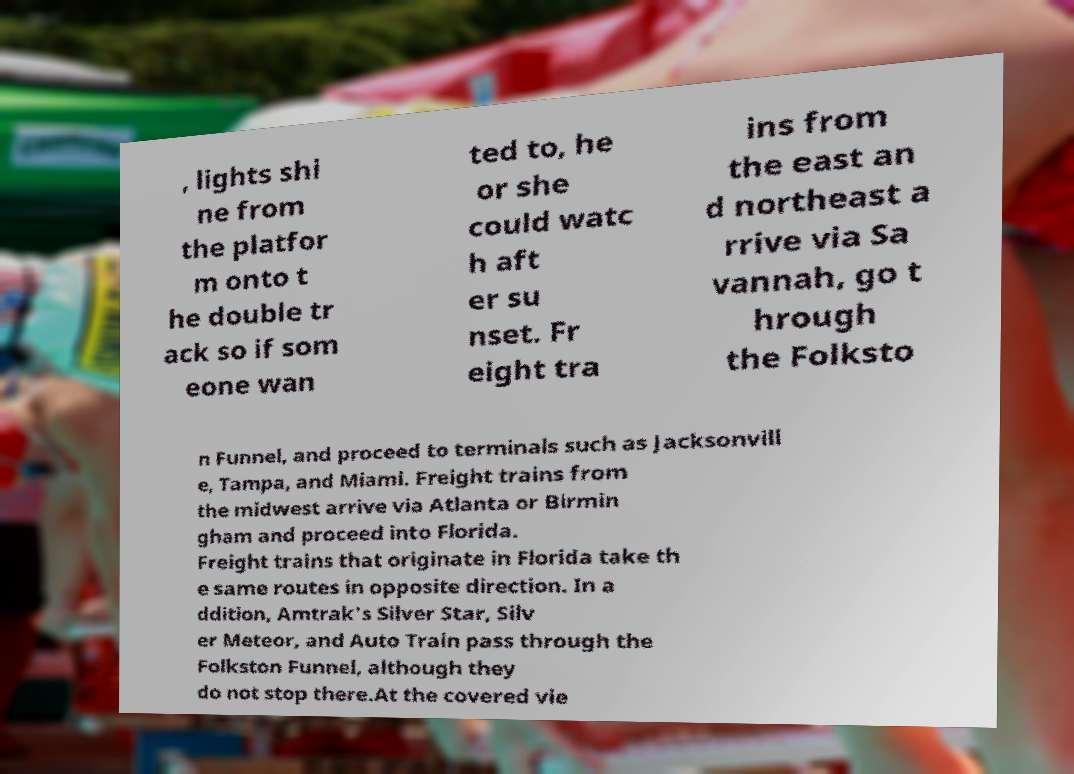Please identify and transcribe the text found in this image. , lights shi ne from the platfor m onto t he double tr ack so if som eone wan ted to, he or she could watc h aft er su nset. Fr eight tra ins from the east an d northeast a rrive via Sa vannah, go t hrough the Folksto n Funnel, and proceed to terminals such as Jacksonvill e, Tampa, and Miami. Freight trains from the midwest arrive via Atlanta or Birmin gham and proceed into Florida. Freight trains that originate in Florida take th e same routes in opposite direction. In a ddition, Amtrak's Silver Star, Silv er Meteor, and Auto Train pass through the Folkston Funnel, although they do not stop there.At the covered vie 